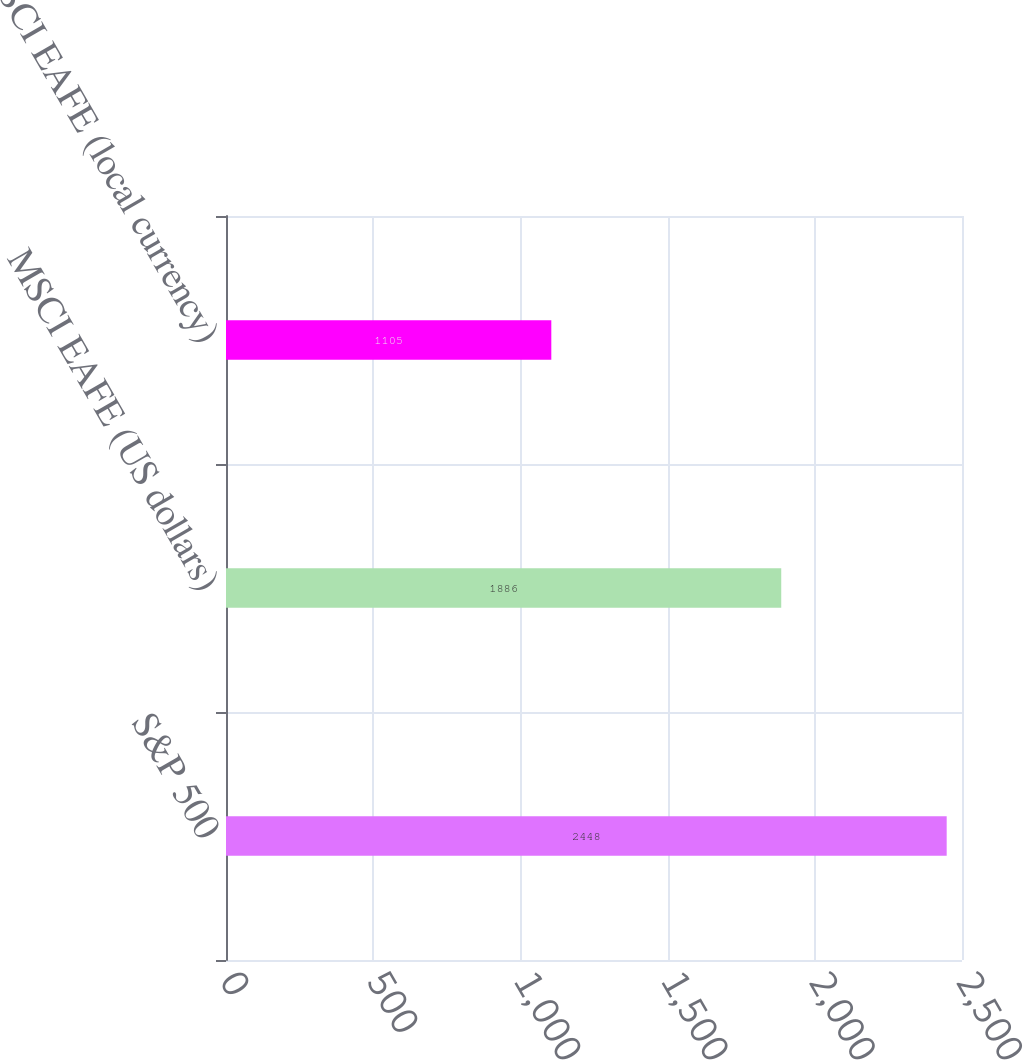<chart> <loc_0><loc_0><loc_500><loc_500><bar_chart><fcel>S&P 500<fcel>MSCI EAFE (US dollars)<fcel>MSCI EAFE (local currency)<nl><fcel>2448<fcel>1886<fcel>1105<nl></chart> 